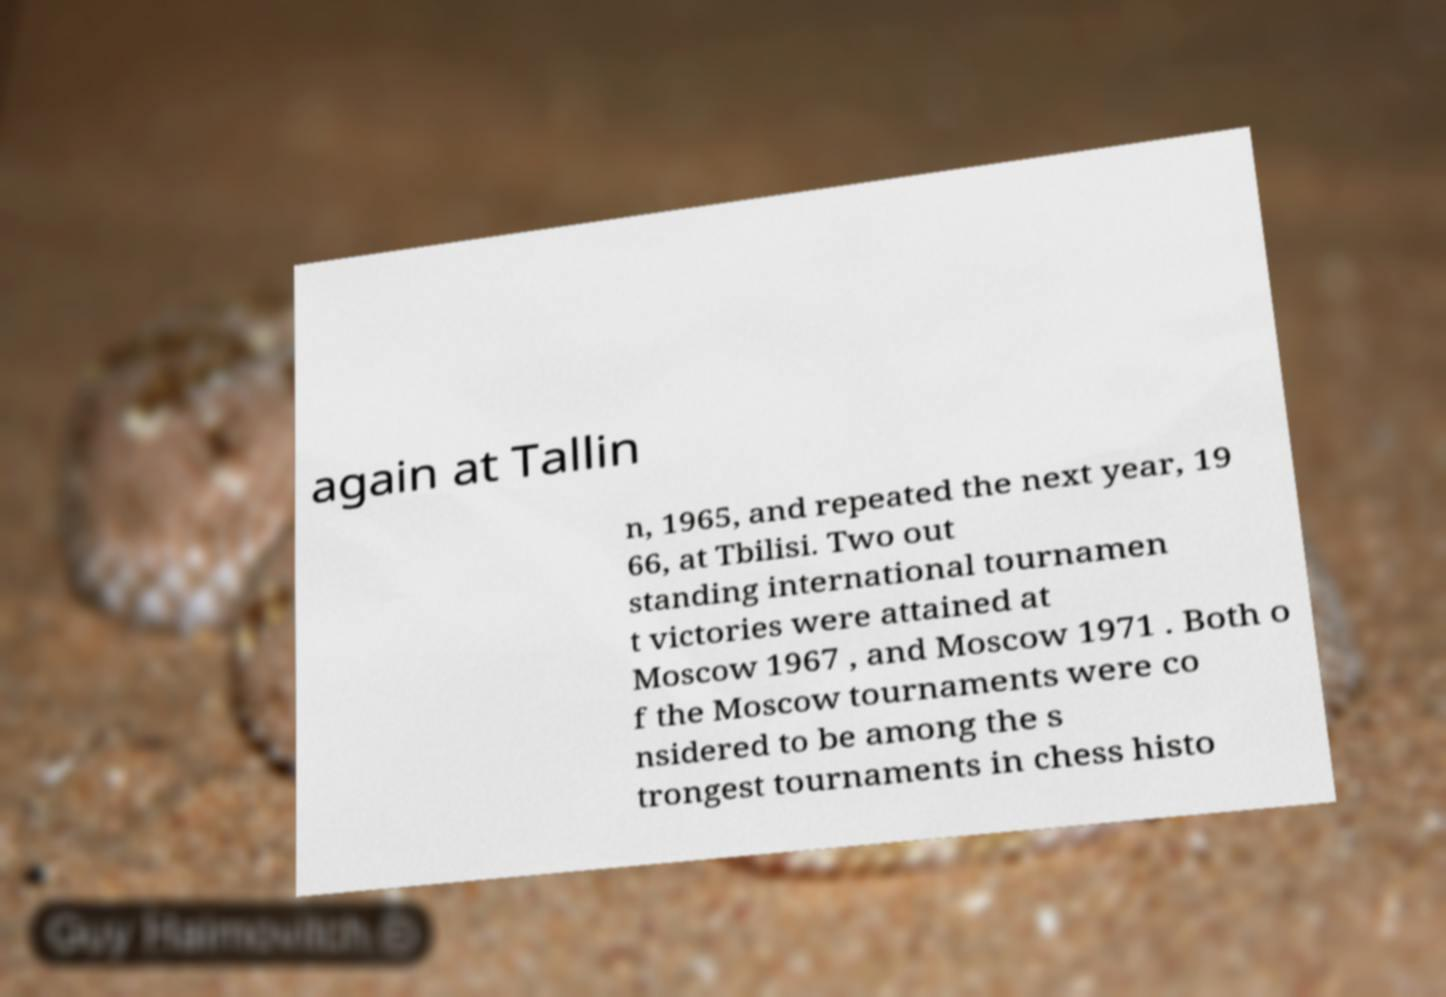What messages or text are displayed in this image? I need them in a readable, typed format. again at Tallin n, 1965, and repeated the next year, 19 66, at Tbilisi. Two out standing international tournamen t victories were attained at Moscow 1967 , and Moscow 1971 . Both o f the Moscow tournaments were co nsidered to be among the s trongest tournaments in chess histo 